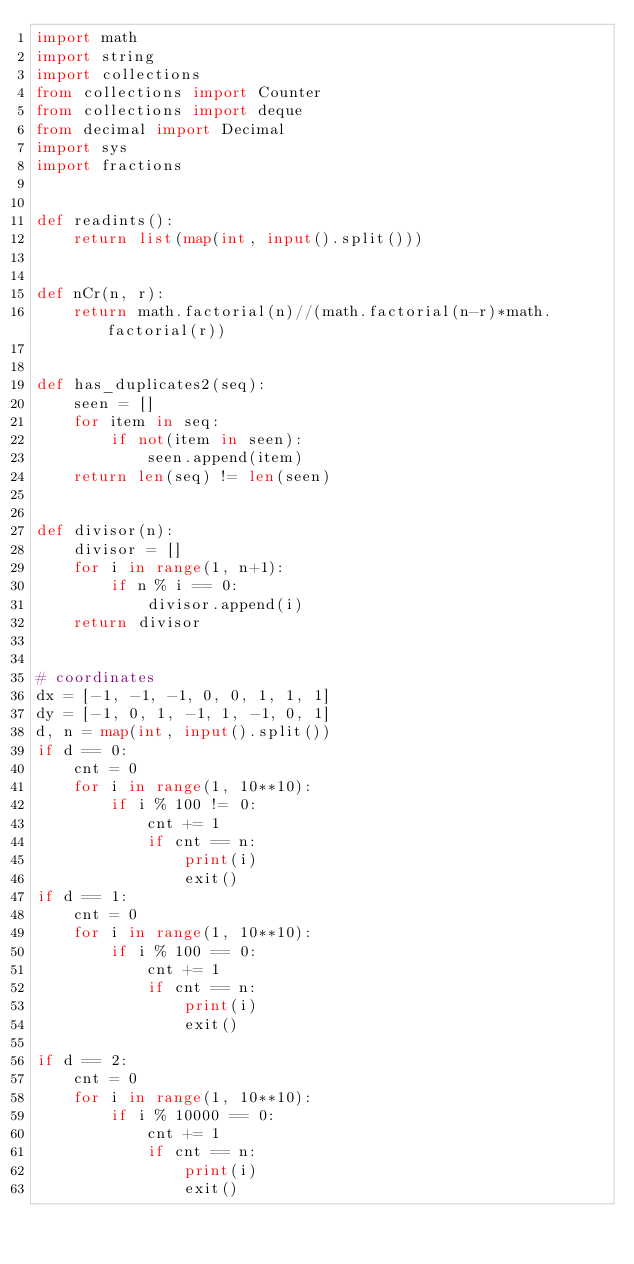Convert code to text. <code><loc_0><loc_0><loc_500><loc_500><_Python_>import math
import string
import collections
from collections import Counter
from collections import deque
from decimal import Decimal
import sys
import fractions


def readints():
    return list(map(int, input().split()))


def nCr(n, r):
    return math.factorial(n)//(math.factorial(n-r)*math.factorial(r))


def has_duplicates2(seq):
    seen = []
    for item in seq:
        if not(item in seen):
            seen.append(item)
    return len(seq) != len(seen)


def divisor(n):
    divisor = []
    for i in range(1, n+1):
        if n % i == 0:
            divisor.append(i)
    return divisor


# coordinates
dx = [-1, -1, -1, 0, 0, 1, 1, 1]
dy = [-1, 0, 1, -1, 1, -1, 0, 1]
d, n = map(int, input().split())
if d == 0:
    cnt = 0
    for i in range(1, 10**10):
        if i % 100 != 0:
            cnt += 1
            if cnt == n:
                print(i)
                exit()
if d == 1:
    cnt = 0
    for i in range(1, 10**10):
        if i % 100 == 0:
            cnt += 1
            if cnt == n:
                print(i)
                exit()

if d == 2:
    cnt = 0
    for i in range(1, 10**10):
        if i % 10000 == 0:
            cnt += 1
            if cnt == n:
                print(i)
                exit()
</code> 